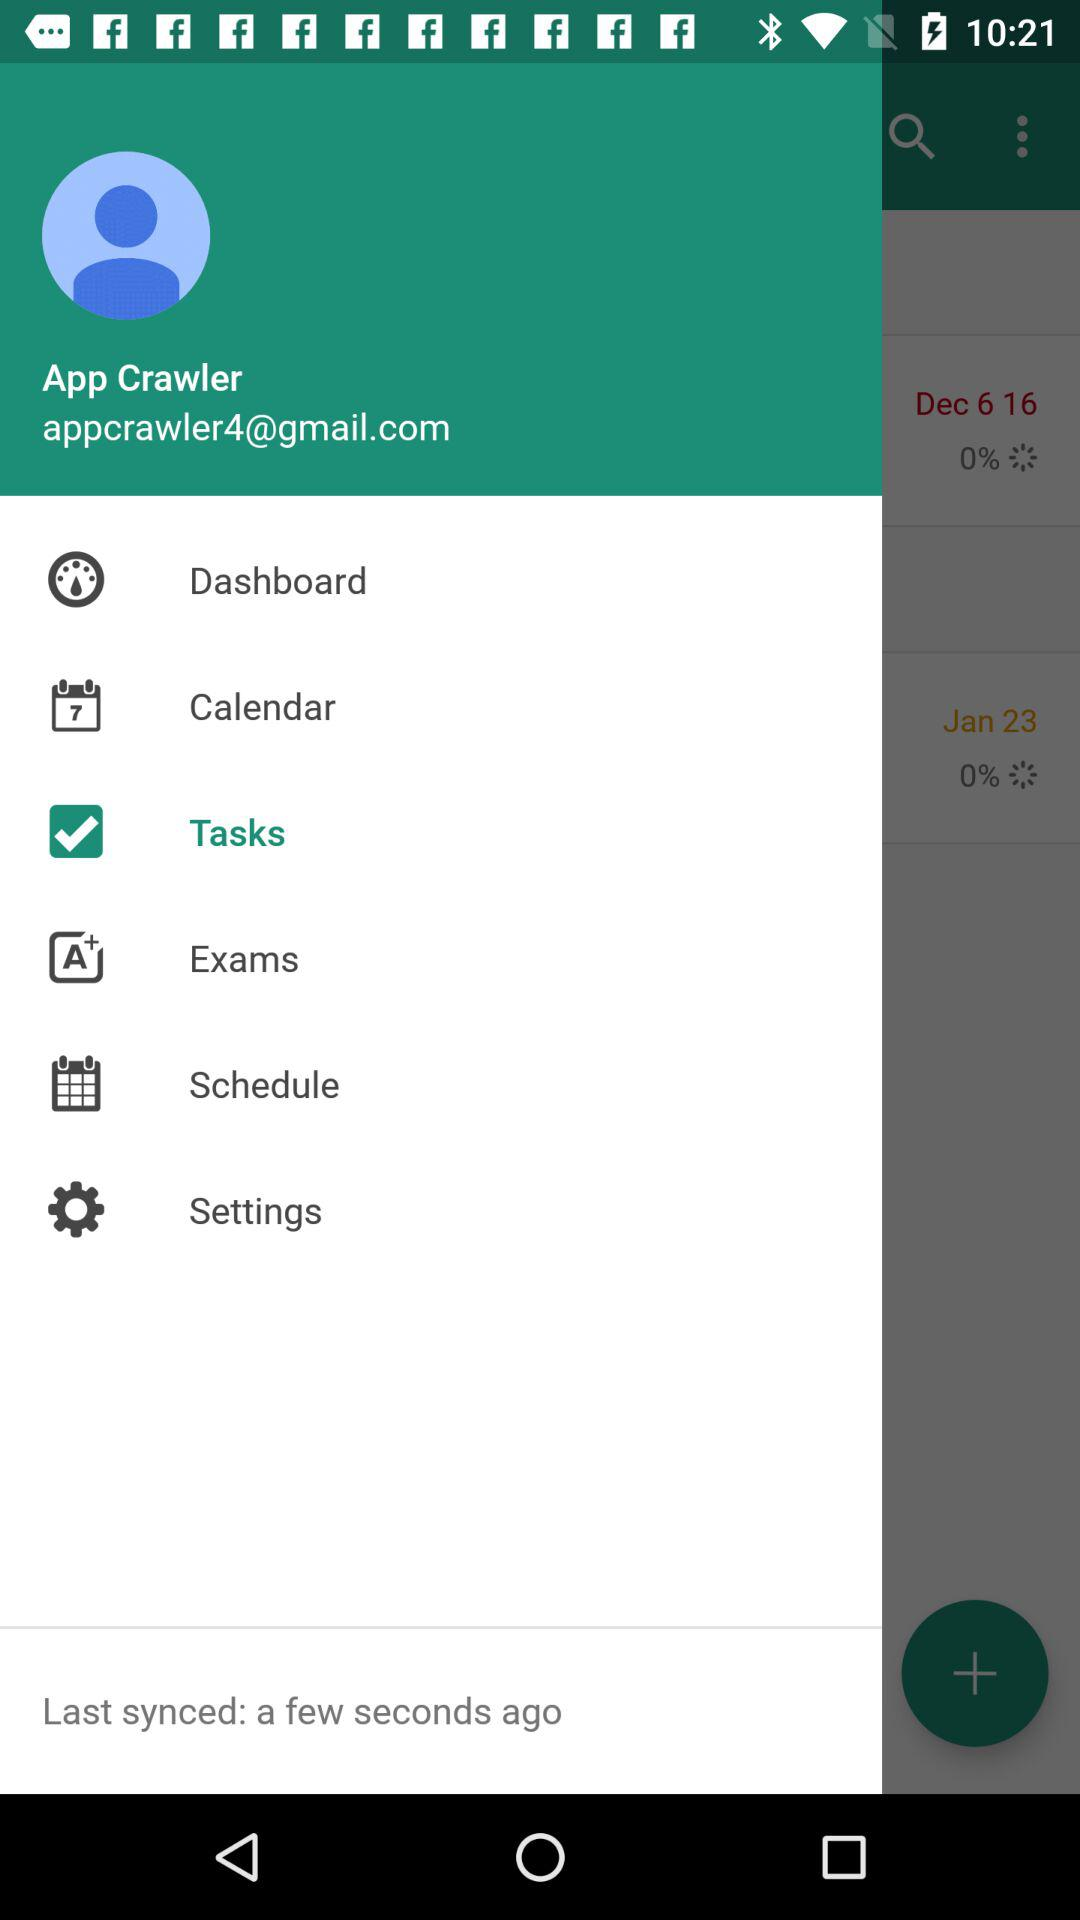What is the given Gmail address? The given Gmail address is appcrawler4@gmail.com. 